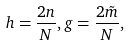<formula> <loc_0><loc_0><loc_500><loc_500>h = \frac { 2 n } { N } , g = \frac { 2 \tilde { m } } { N } ,</formula> 